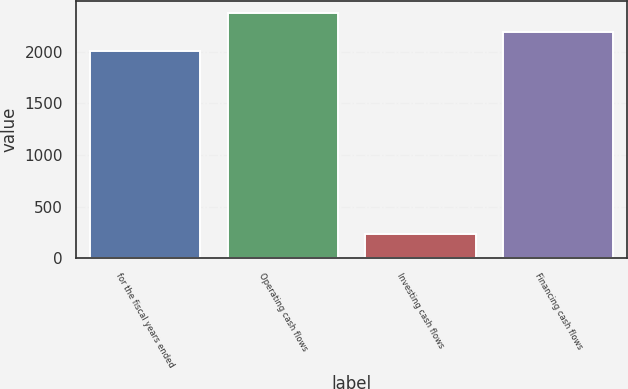Convert chart to OTSL. <chart><loc_0><loc_0><loc_500><loc_500><bar_chart><fcel>for the fiscal years ended<fcel>Operating cash flows<fcel>Investing cash flows<fcel>Financing cash flows<nl><fcel>2013<fcel>2373.56<fcel>232.9<fcel>2193.28<nl></chart> 